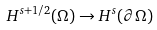Convert formula to latex. <formula><loc_0><loc_0><loc_500><loc_500>H ^ { s + 1 / 2 } ( \Omega ) \rightarrow H ^ { s } ( \partial \Omega )</formula> 